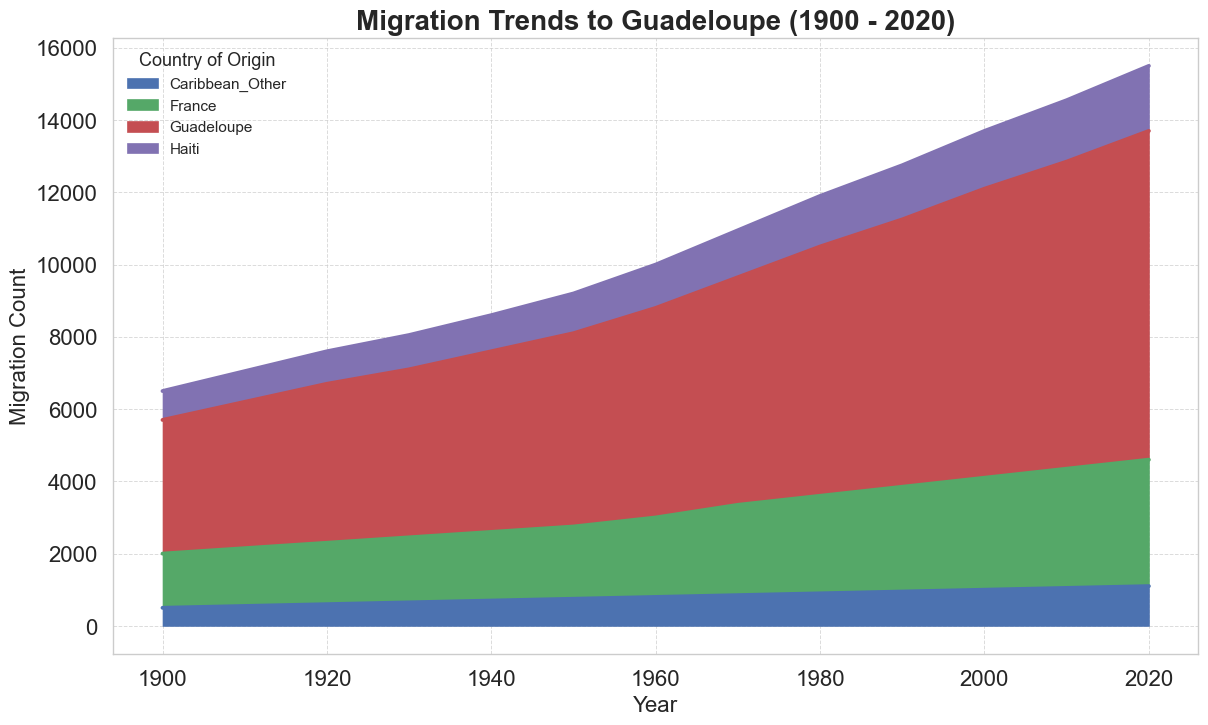What is the total migration count to Guadeloupe from France in 1940? To find the total migration count to Guadeloupe from France in 1940, locate the data point corresponding to France in that year. The figure indicates that 1,900 people migrated from France to Guadeloupe in 1940.
Answer: 1,900 Which country had a higher migration count to Guadeloupe in 1950, France or Haiti? Compare the heights of the areas representing migration from France and Haiti to Guadeloupe in 1950. France has a higher area section, indicating 2,000 migrants, while Haiti has 1,100 migrants.
Answer: France How did the migration trend from Haiti to Guadeloupe change from 1900 to 2020? Look at the overall area representing migration from Haiti to Guadeloupe from 1900 to 2020. The trend shows an increase in migration from 800 in 1900 to 1,800 in 2020.
Answer: Increased What is the difference in migration count from Guadeloupe to France between 1980 and 2020? Identify the migration counts from Guadeloupe to France for both years. In 1980, it was 3,500, and in 2020, it was 4,500. The difference is 4,500 - 3,500 = 1,000.
Answer: 1,000 Which year experienced the highest overall migration count to Guadeloupe? Examine the peaks of the aggregated areas in the area chart. The year 2020 appears to be the highest, summing sections for France, Haiti, and Caribbean_Other.
Answer: 2020 How does the migration trend from the Caribbean_Other to Guadeloupe in 2020 compare to that in 1900? Observe the area representing migration from Caribbean_Other in both years. The migration increased from 500 in 1900 to 1,100 in 2020.
Answer: Increased During what period did migration from France to Guadeloupe show the most significant increase? By scanning the area specific to migration from France, determine the period where the slope is steepest. The period from 1950 to 1960 shows a notable increase from 2,000 to 2,200.
Answer: 1950-1960 What is the cumulative migration count from Haiti to Guadeloupe in the decade of the 1960s? Sum the migration counts for each year in the 1960s. The values are 1,200 for 1960 and 1,300 for 1970. Thus, 1,200 + 1,300 = 2,500.
Answer: 2,500 By how much does migration from France to Guadeloupe in 2000 surpass the migration from Caribbean_Other to Guadeloupe in the same year? Locate the migration counts for 2000. Migration from France is 3,100, and from Caribbean_Other is 1,000. The difference is 3,100 - 1,000 = 2,100.
Answer: 2,100 